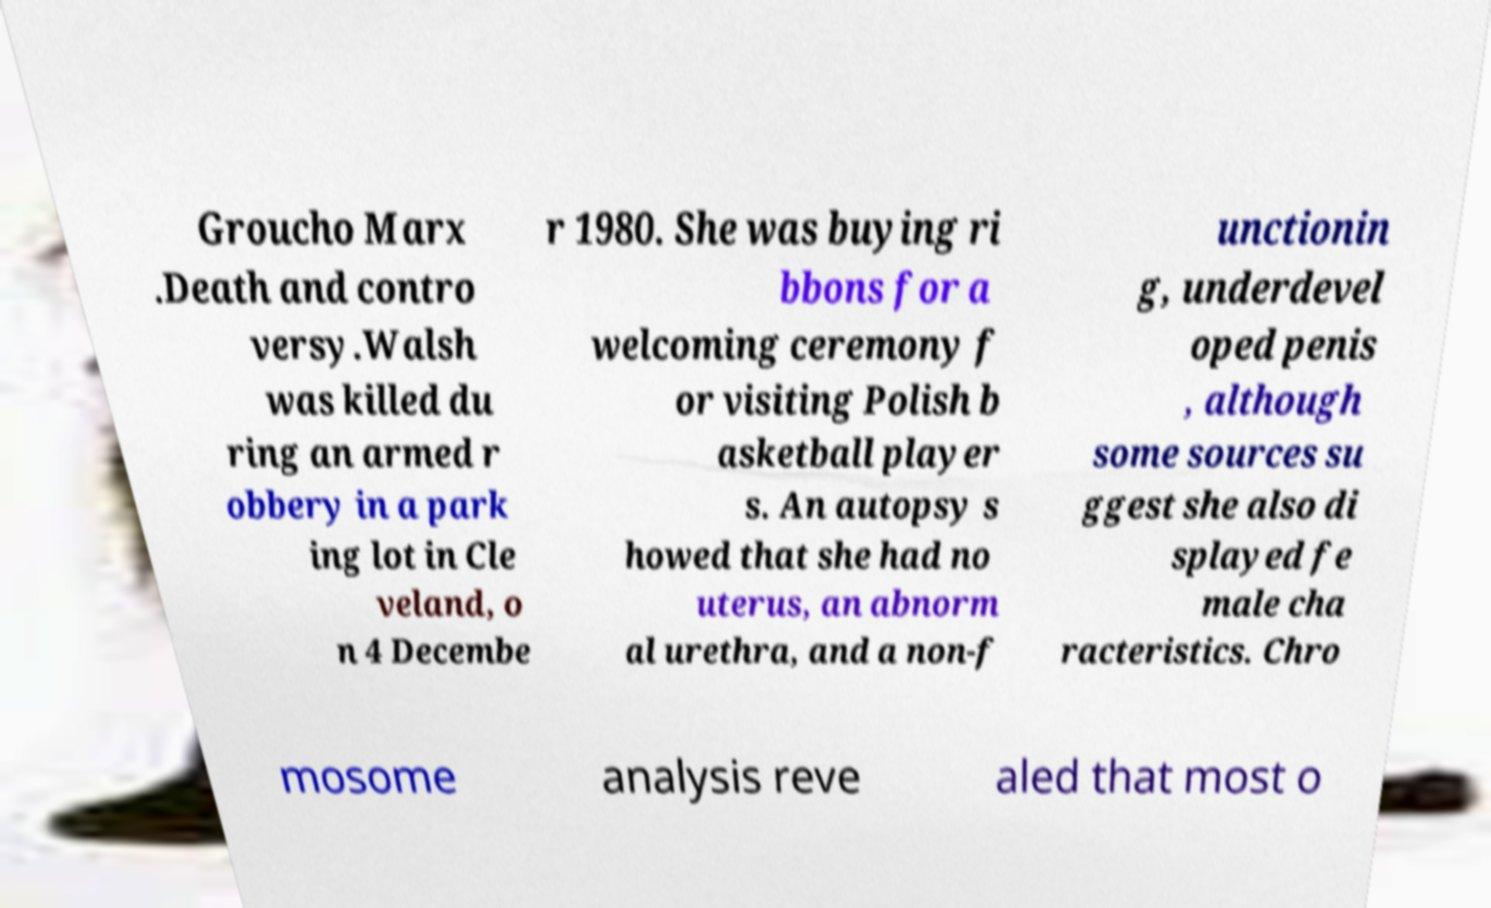Can you accurately transcribe the text from the provided image for me? Groucho Marx .Death and contro versy.Walsh was killed du ring an armed r obbery in a park ing lot in Cle veland, o n 4 Decembe r 1980. She was buying ri bbons for a welcoming ceremony f or visiting Polish b asketball player s. An autopsy s howed that she had no uterus, an abnorm al urethra, and a non-f unctionin g, underdevel oped penis , although some sources su ggest she also di splayed fe male cha racteristics. Chro mosome analysis reve aled that most o 